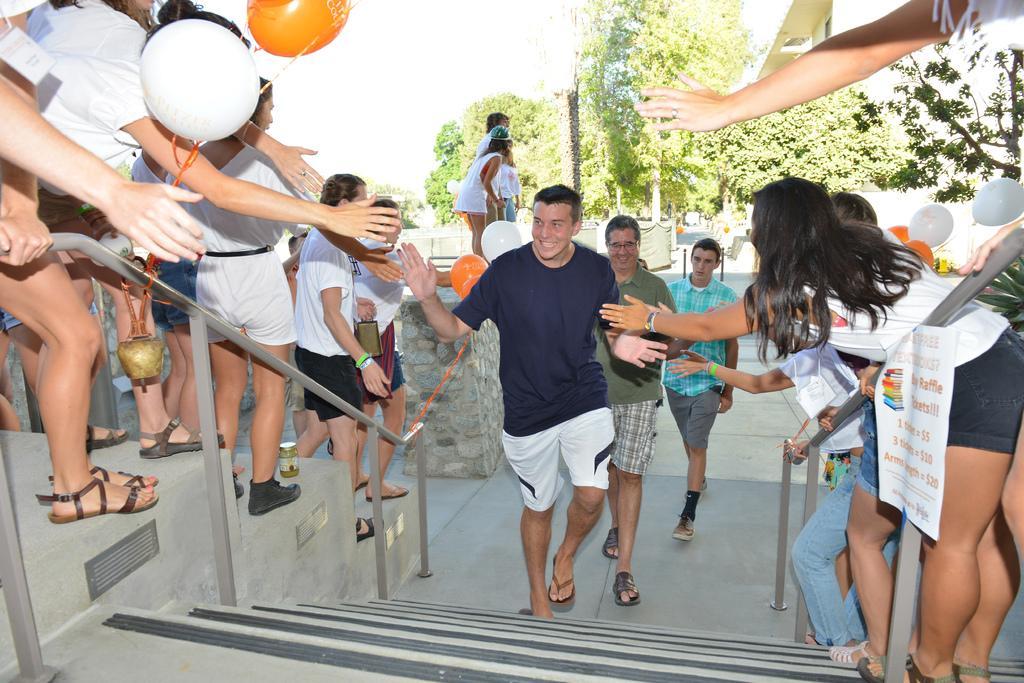Please provide a concise description of this image. In this image I can see stairs in the front and on the both side of it I can see railings and number of balloons. I can also see number of people are standing in the front and in the background I can see number of trees. On the right side of this image I can see a white colour paper and on it I can see something is written. I can also see most of them are wearing white colour dress. 